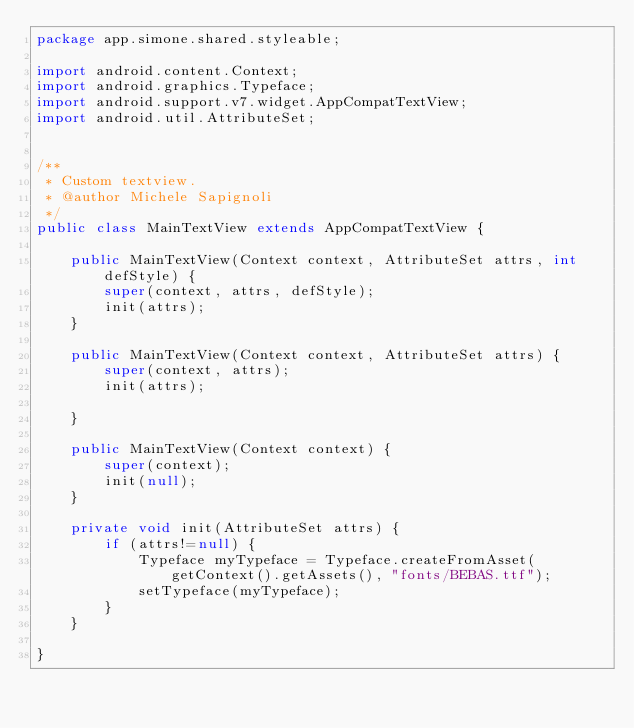<code> <loc_0><loc_0><loc_500><loc_500><_Java_>package app.simone.shared.styleable;

import android.content.Context;
import android.graphics.Typeface;
import android.support.v7.widget.AppCompatTextView;
import android.util.AttributeSet;


/**
 * Custom textview.
 * @author Michele Sapignoli
 */
public class MainTextView extends AppCompatTextView {

    public MainTextView(Context context, AttributeSet attrs, int defStyle) {
        super(context, attrs, defStyle);
        init(attrs);
    }

    public MainTextView(Context context, AttributeSet attrs) {
        super(context, attrs);
        init(attrs);

    }

    public MainTextView(Context context) {
        super(context);
        init(null);
    }

    private void init(AttributeSet attrs) {
        if (attrs!=null) {
            Typeface myTypeface = Typeface.createFromAsset(getContext().getAssets(), "fonts/BEBAS.ttf");
            setTypeface(myTypeface);
        }
    }

}</code> 